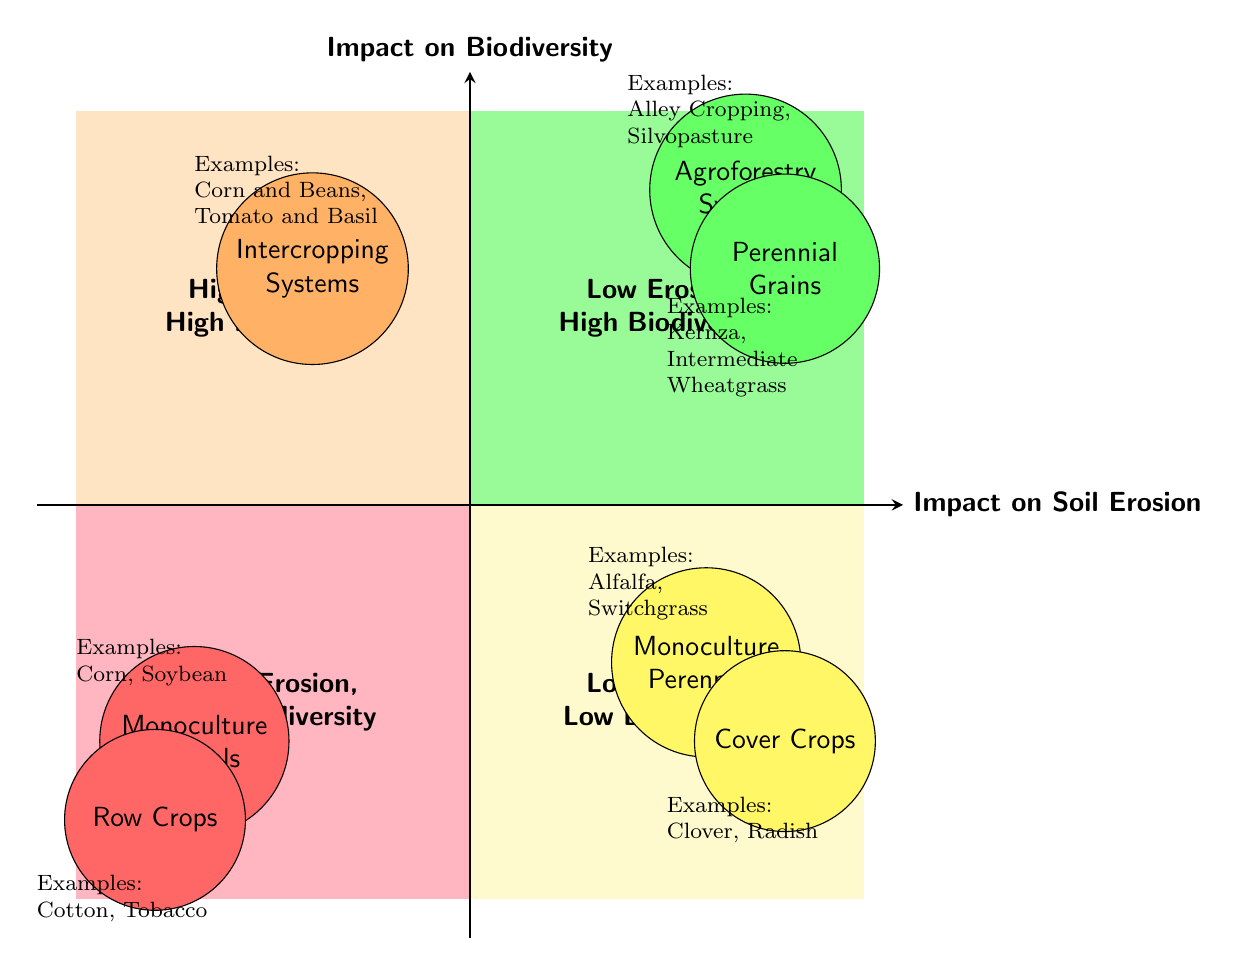What crop type appears in the "Low Erosion, High Biodiversity" quadrant? In the "Low Erosion, High Biodiversity" quadrant, the crop types listed are "Agroforestry Systems" and "Perennial Grains".
Answer: Agroforestry Systems, Perennial Grains How many crop types are represented in the "High Erosion, Low Biodiversity" quadrant? The "High Erosion, Low Biodiversity" quadrant contains two crop types: "Monoculture Annuals" and "Row Crops".
Answer: 2 Which crop type has examples listed as "Clover, Radish"? The crop type with examples "Clover, Radish" is "Cover Crops", which is found in the "Low Erosion, Low Biodiversity" quadrant.
Answer: Cover Crops What is the relationship between "Intercropping Systems" and "High Erosion"? "Intercropping Systems" exist in the "High Erosion, High Biodiversity" quadrant, meaning they have a high impact on erosion while also enhancing biodiversity.
Answer: Exists in the same quadrant What type of crops would lead to significant soil erosion and low biodiversity? "Monoculture Annuals" and "Row Crops" are types of crops that lead to significant soil erosion and low biodiversity, as detailed in the "High Erosion, Low Biodiversity" quadrant.
Answer: Monoculture Annuals, Row Crops Which crop type reduces soil erosion but does not support high biodiversity? "Monoculture Perennials" are crops that reduce soil erosion due to their deep roots but do not support high biodiversity.
Answer: Monoculture Perennials What examples are listed for "Agroforestry Systems"? The examples listed for "Agroforestry Systems" are "Alley Cropping" and "Silvopasture".
Answer: Alley Cropping, Silvopasture In which quadrant would you find crops that combine multiple species? Crops that combine multiple species, such as "Intercropping Systems", are found in the "High Erosion, High Biodiversity" quadrant.
Answer: High Erosion, High Biodiversity What quadrant contains "Monoculture Perennials"? "Monoculture Perennials" are located in the "Low Erosion, Low Biodiversity" quadrant.
Answer: Low Erosion, Low Biodiversity 